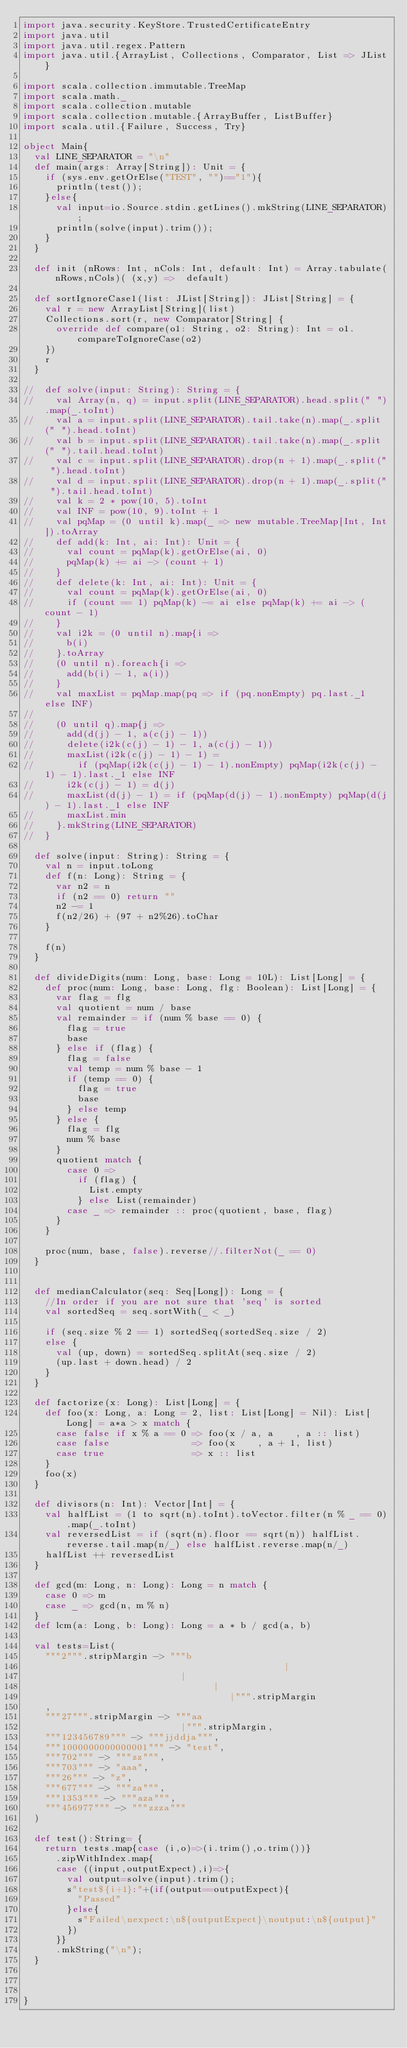Convert code to text. <code><loc_0><loc_0><loc_500><loc_500><_Scala_>import java.security.KeyStore.TrustedCertificateEntry
import java.util
import java.util.regex.Pattern
import java.util.{ArrayList, Collections, Comparator, List => JList}

import scala.collection.immutable.TreeMap
import scala.math._
import scala.collection.mutable
import scala.collection.mutable.{ArrayBuffer, ListBuffer}
import scala.util.{Failure, Success, Try}

object Main{
  val LINE_SEPARATOR = "\n"
  def main(args: Array[String]): Unit = {
    if (sys.env.getOrElse("TEST", "")=="1"){
      println(test());
    }else{
      val input=io.Source.stdin.getLines().mkString(LINE_SEPARATOR);
      println(solve(input).trim());
    }
  }

  def init (nRows: Int, nCols: Int, default: Int) = Array.tabulate(nRows,nCols)( (x,y) =>  default)

  def sortIgnoreCase1(list: JList[String]): JList[String] = {
    val r = new ArrayList[String](list)
    Collections.sort(r, new Comparator[String] {
      override def compare(o1: String, o2: String): Int = o1.compareToIgnoreCase(o2)
    })
    r
  }

//  def solve(input: String): String = {
//    val Array(n, q) = input.split(LINE_SEPARATOR).head.split(" ").map(_.toInt)
//    val a = input.split(LINE_SEPARATOR).tail.take(n).map(_.split(" ").head.toInt)
//    val b = input.split(LINE_SEPARATOR).tail.take(n).map(_.split(" ").tail.head.toInt)
//    val c = input.split(LINE_SEPARATOR).drop(n + 1).map(_.split(" ").head.toInt)
//    val d = input.split(LINE_SEPARATOR).drop(n + 1).map(_.split(" ").tail.head.toInt)
//    val k = 2 * pow(10, 5).toInt
//    val INF = pow(10, 9).toInt + 1
//    val pqMap = (0 until k).map(_ => new mutable.TreeMap[Int, Int]).toArray
//    def add(k: Int, ai: Int): Unit = {
//      val count = pqMap(k).getOrElse(ai, 0)
//      pqMap(k) += ai -> (count + 1)
//    }
//    def delete(k: Int, ai: Int): Unit = {
//      val count = pqMap(k).getOrElse(ai, 0)
//      if (count == 1) pqMap(k) -= ai else pqMap(k) += ai -> (count - 1)
//    }
//    val i2k = (0 until n).map{i =>
//      b(i)
//    }.toArray
//    (0 until n).foreach{i =>
//      add(b(i) - 1, a(i))
//    }
//    val maxList = pqMap.map(pq => if (pq.nonEmpty) pq.last._1 else INF)
//
//    (0 until q).map{j =>
//      add(d(j) - 1, a(c(j) - 1))
//      delete(i2k(c(j) - 1) - 1, a(c(j) - 1))
//      maxList(i2k(c(j) - 1) - 1) =
//        if (pqMap(i2k(c(j) - 1) - 1).nonEmpty) pqMap(i2k(c(j) - 1) - 1).last._1 else INF
//      i2k(c(j) - 1) = d(j)
//      maxList(d(j) - 1) = if (pqMap(d(j) - 1).nonEmpty) pqMap(d(j) - 1).last._1 else INF
//      maxList.min
//    }.mkString(LINE_SEPARATOR)
//  }

  def solve(input: String): String = {
    val n = input.toLong
    def f(n: Long): String = {
      var n2 = n
      if (n2 == 0) return ""
      n2 -= 1
      f(n2/26) + (97 + n2%26).toChar
    }

    f(n)
  }

  def divideDigits(num: Long, base: Long = 10L): List[Long] = {
    def proc(num: Long, base: Long, flg: Boolean): List[Long] = {
      var flag = flg
      val quotient = num / base
      val remainder = if (num % base == 0) {
        flag = true
        base
      } else if (flag) {
        flag = false
        val temp = num % base - 1
        if (temp == 0) {
          flag = true
          base
        } else temp
      } else {
        flag = flg
        num % base
      }
      quotient match {
        case 0 =>
          if (flag) {
            List.empty
          } else List(remainder)
        case _ => remainder :: proc(quotient, base, flag)
      }
    }

    proc(num, base, false).reverse//.filterNot(_ == 0)
  }


  def medianCalculator(seq: Seq[Long]): Long = {
    //In order if you are not sure that 'seq' is sorted
    val sortedSeq = seq.sortWith(_ < _)

    if (seq.size % 2 == 1) sortedSeq(sortedSeq.size / 2)
    else {
      val (up, down) = sortedSeq.splitAt(seq.size / 2)
      (up.last + down.head) / 2
    }
  }

  def factorize(x: Long): List[Long] = {
    def foo(x: Long, a: Long = 2, list: List[Long] = Nil): List[Long] = a*a > x match {
      case false if x % a == 0 => foo(x / a, a    , a :: list)
      case false               => foo(x    , a + 1, list)
      case true                => x :: list
    }
    foo(x)
  }

  def divisors(n: Int): Vector[Int] = {
    val halfList = (1 to sqrt(n).toInt).toVector.filter(n % _ == 0).map(_.toInt)
    val reversedList = if (sqrt(n).floor == sqrt(n)) halfList.reverse.tail.map(n/_) else halfList.reverse.map(n/_)
    halfList ++ reversedList
  }

  def gcd(m: Long, n: Long): Long = n match {
    case 0 => m
    case _ => gcd(n, m % n)
  }
  def lcm(a: Long, b: Long): Long = a * b / gcd(a, b)

  val tests=List(
    """2""".stripMargin -> """b
                                                |
                             |
                                   |
                                      |""".stripMargin
    ,
    """27""".stripMargin -> """aa
                             |""".stripMargin,
    """123456789""" -> """jjddja""",
    """1000000000000001""" -> "test",
    """702""" -> """zz""",
    """703""" -> "aaa",
    """26""" -> "z",
    """677""" -> """za""",
    """1353""" -> """aza""",
    """456977""" -> """zzza"""
  )

  def test():String= {
    return tests.map{case (i,o)=>(i.trim(),o.trim())}
      .zipWithIndex.map{
      case ((input,outputExpect),i)=>{
        val output=solve(input).trim();
        s"test${i+1}:"+(if(output==outputExpect){
          "Passed"
        }else{
          s"Failed\nexpect:\n${outputExpect}\noutput:\n${output}"
        })
      }}
      .mkString("\n");
  }



}
</code> 